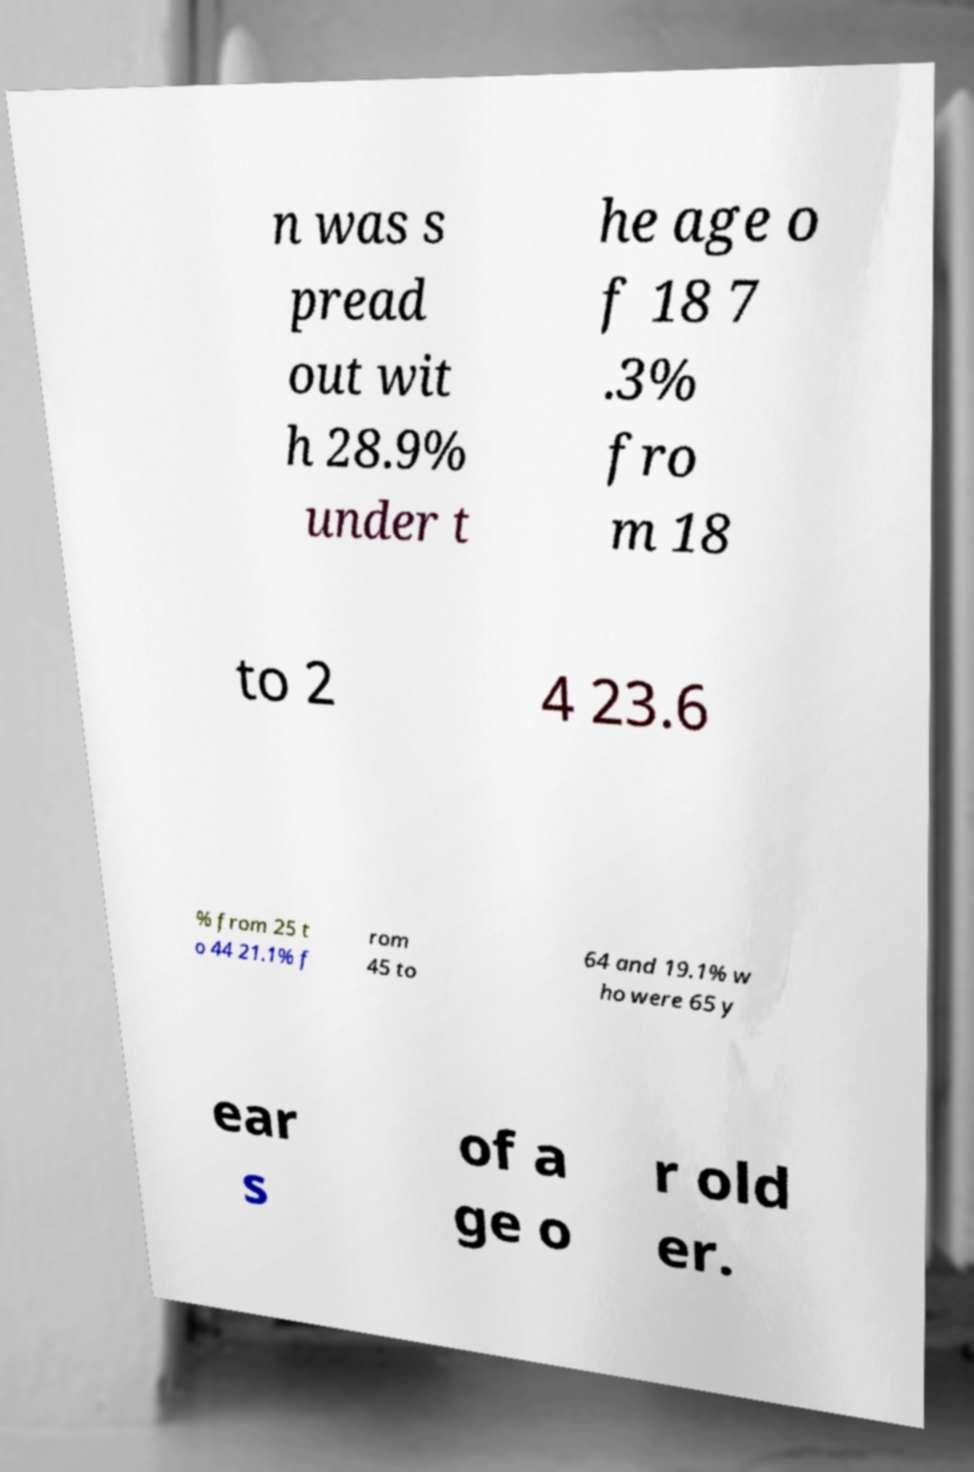There's text embedded in this image that I need extracted. Can you transcribe it verbatim? n was s pread out wit h 28.9% under t he age o f 18 7 .3% fro m 18 to 2 4 23.6 % from 25 t o 44 21.1% f rom 45 to 64 and 19.1% w ho were 65 y ear s of a ge o r old er. 